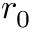<formula> <loc_0><loc_0><loc_500><loc_500>r _ { 0 }</formula> 